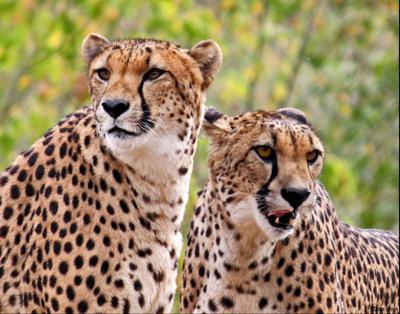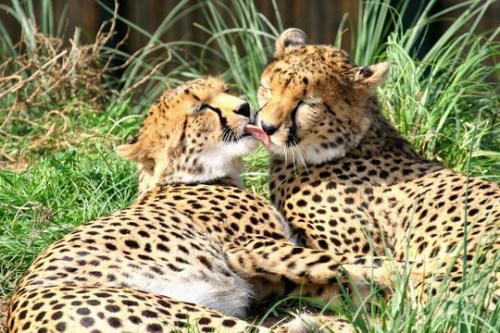The first image is the image on the left, the second image is the image on the right. For the images shown, is this caption "There are a pair of cheetahs laying on the grown while one is grooming the other." true? Answer yes or no. Yes. The first image is the image on the left, the second image is the image on the right. Assess this claim about the two images: "All of the cheetahs are laying down.". Correct or not? Answer yes or no. No. 